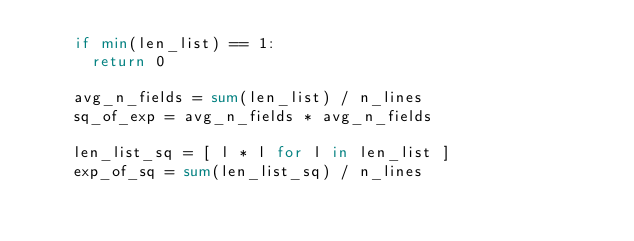Convert code to text. <code><loc_0><loc_0><loc_500><loc_500><_Python_>    if min(len_list) == 1:
      return 0

    avg_n_fields = sum(len_list) / n_lines
    sq_of_exp = avg_n_fields * avg_n_fields

    len_list_sq = [ l * l for l in len_list ]
    exp_of_sq = sum(len_list_sq) / n_lines</code> 